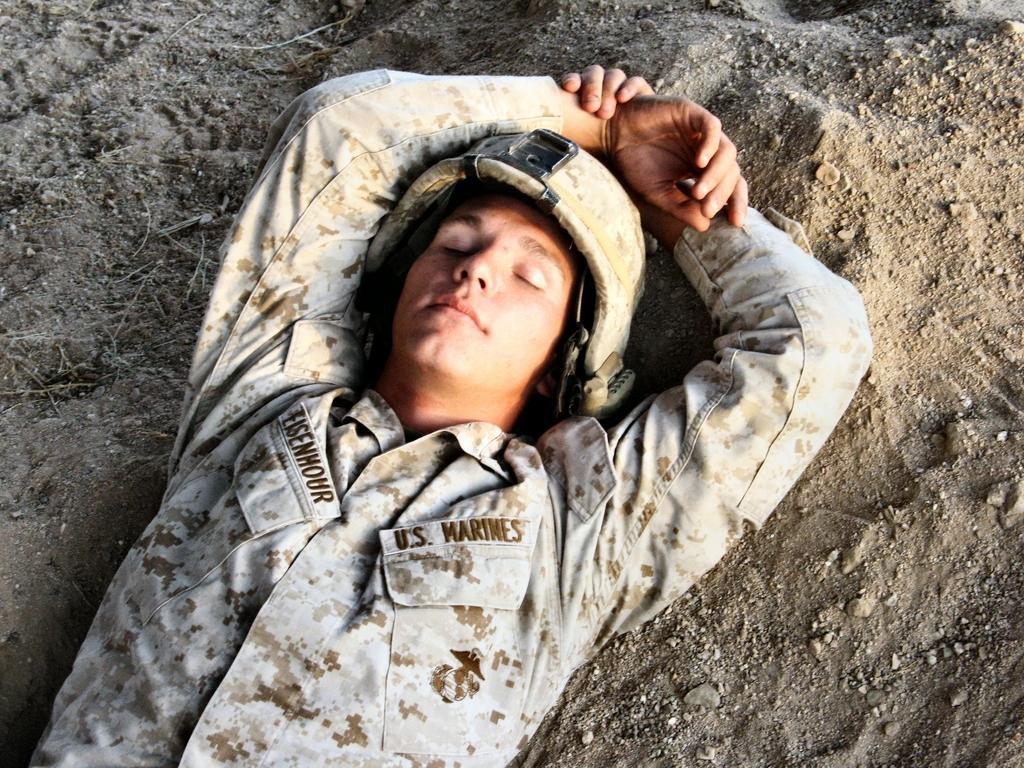Please provide a concise description of this image. Here in this picture we can see a person in army dress laying on the ground over there and he is also wearing helmet on him. 